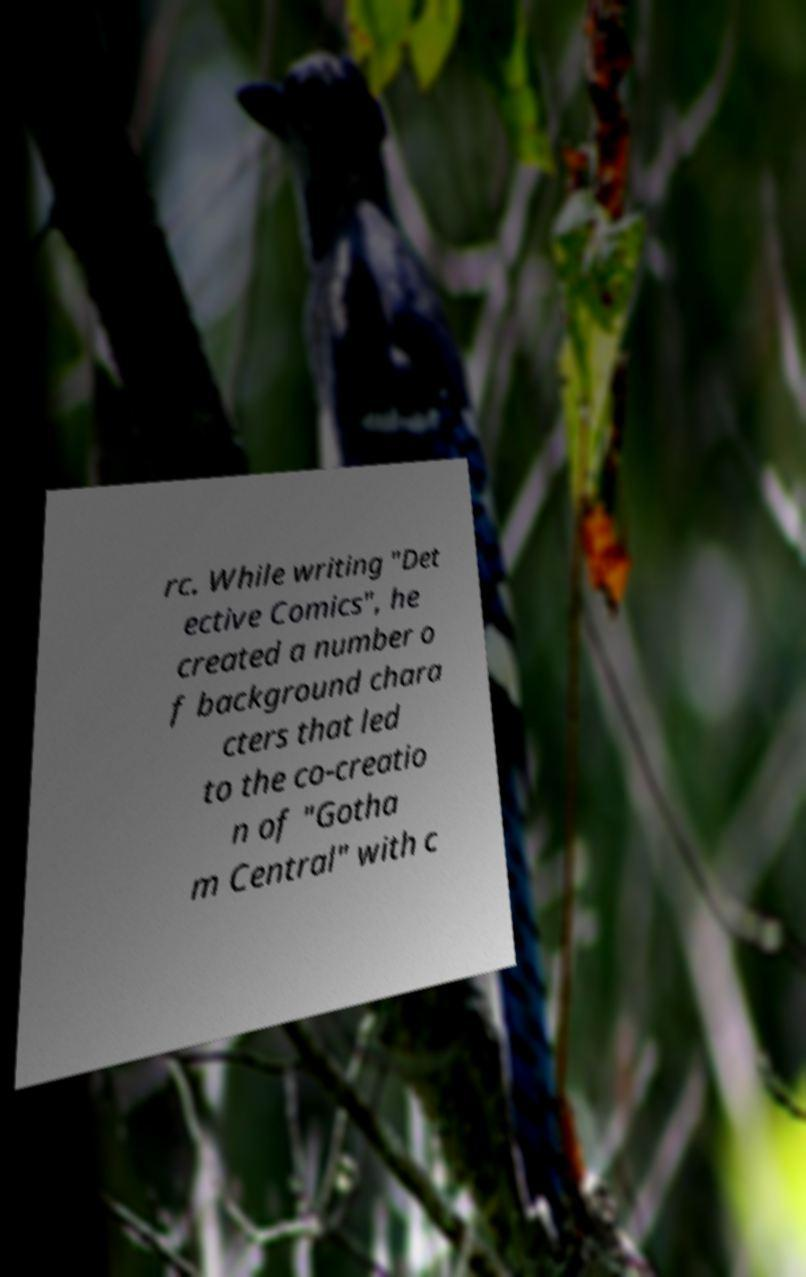Please identify and transcribe the text found in this image. rc. While writing "Det ective Comics", he created a number o f background chara cters that led to the co-creatio n of "Gotha m Central" with c 